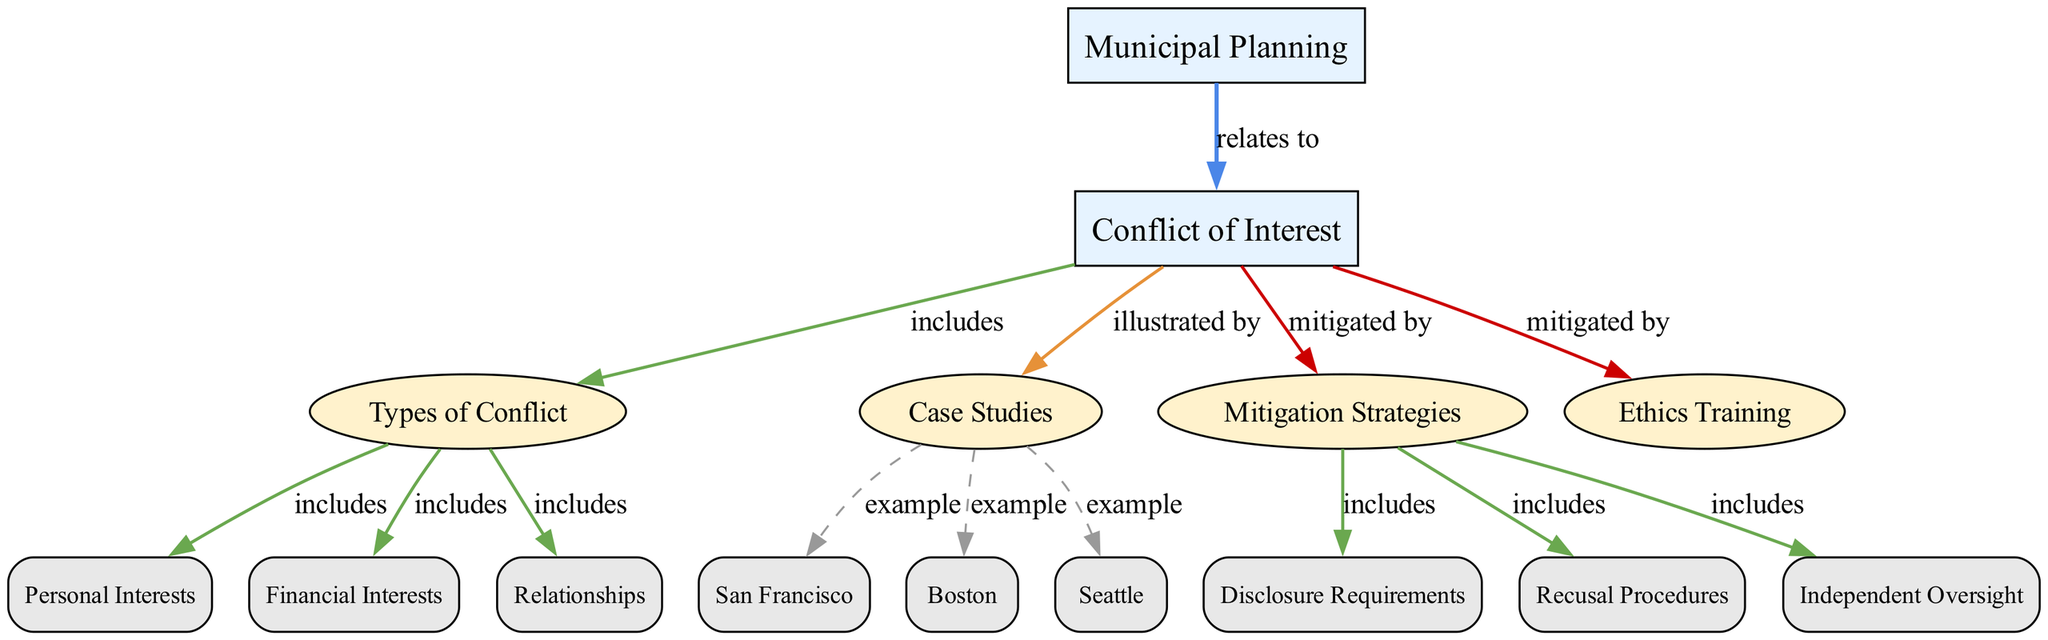What is the main topic of the concept map? The main topic is represented by the first node labeled "Municipal Planning." It establishes the primary focus of the diagram, indicating that the subsequent discussions will revolve around this central theme.
Answer: Municipal Planning How many types of conflicts are included in the diagram? The node "types of conflict" indicates it includes three categories: personal interests, financial interests, and relationship interests. We identify these through the edges branching from that node.
Answer: Three Which case study is associated with San Francisco? The diagram demonstrates that the edge leading to "San Francisco" is categorized as "example" from the "case studies" node, indicating it is one of several cases that exemplify the conflict of interest in municipal planning.
Answer: San Francisco What mitigation strategy involves separating officials from decision-making? The node "Recusal Procedures" directly links to "mitigation strategies" and highlights a process designed to prevent conflicts by requiring officials to abstain from engagement in particular decisions where they have a conflict.
Answer: Recusal Procedures What type of interests does "relationship_interest" refer to? "Relationship_interest" is categorized under the "types of conflict" node, which includes various conflicts related to personal or professional relations, indicating the nature of conflicts arising from personal connections.
Answer: Relationships In total, how many case studies are illustrated in the map? The edges connecting the "case studies" node to "case_san_francisco," "case_boston," and "case_seattle" collectively provide three examples, confirming the total number presented.
Answer: Three How is "Disclosure Requirements" categorized in relation to "mitigation strategies"? This term is represented as a tertiary node linked to "mitigation strategies" with an "includes" type edge, suggesting its role as one of the several approaches to manage and mitigate conflicts of interest in municipal planning.
Answer: Disclosure Requirements What type of node is "Ethics Training"? "Ethics Training" is classified as a secondary node based on its visual designation and placement within the diagram, which is distinct from main and tertiary nodes, suggesting its supportive role in addressing conflict of interest issues.
Answer: Secondary 